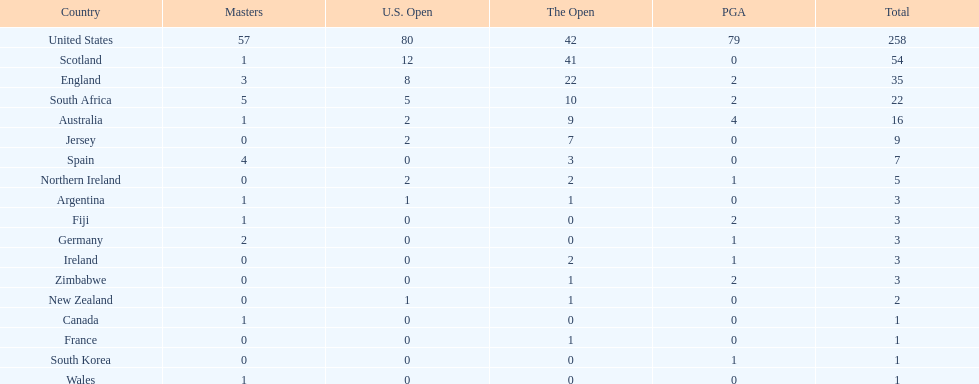In this table, which african country possesses the smallest number of champion golfers? Zimbabwe. 